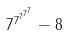<formula> <loc_0><loc_0><loc_500><loc_500>7 ^ { 7 ^ { 7 ^ { 7 ^ { 7 } } } } - 8</formula> 